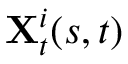<formula> <loc_0><loc_0><loc_500><loc_500>X _ { t } ^ { i } ( s , t )</formula> 